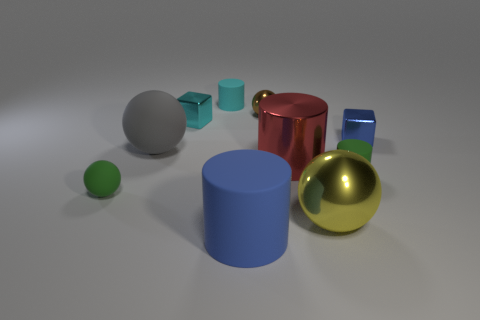There is another ball that is the same material as the yellow ball; what color is it?
Provide a succinct answer. Brown. Are there any blue cylinders that have the same size as the gray sphere?
Make the answer very short. Yes. There is a yellow metal thing that is the same size as the gray sphere; what shape is it?
Offer a terse response. Sphere. Is there a large blue matte object of the same shape as the big yellow thing?
Provide a short and direct response. No. Is the material of the cyan cylinder the same as the blue thing left of the yellow object?
Provide a short and direct response. Yes. Is there a metal cylinder that has the same color as the small metallic sphere?
Make the answer very short. No. There is a large metallic ball; does it have the same color as the metallic thing behind the cyan cube?
Offer a terse response. No. Are there more rubber spheres to the left of the small matte sphere than blue metal objects?
Provide a succinct answer. No. There is a green thing that is right of the green object that is left of the small cyan block; what number of brown shiny things are in front of it?
Offer a terse response. 0. There is a tiny green thing on the right side of the red object; is its shape the same as the red metal thing?
Provide a short and direct response. Yes. 